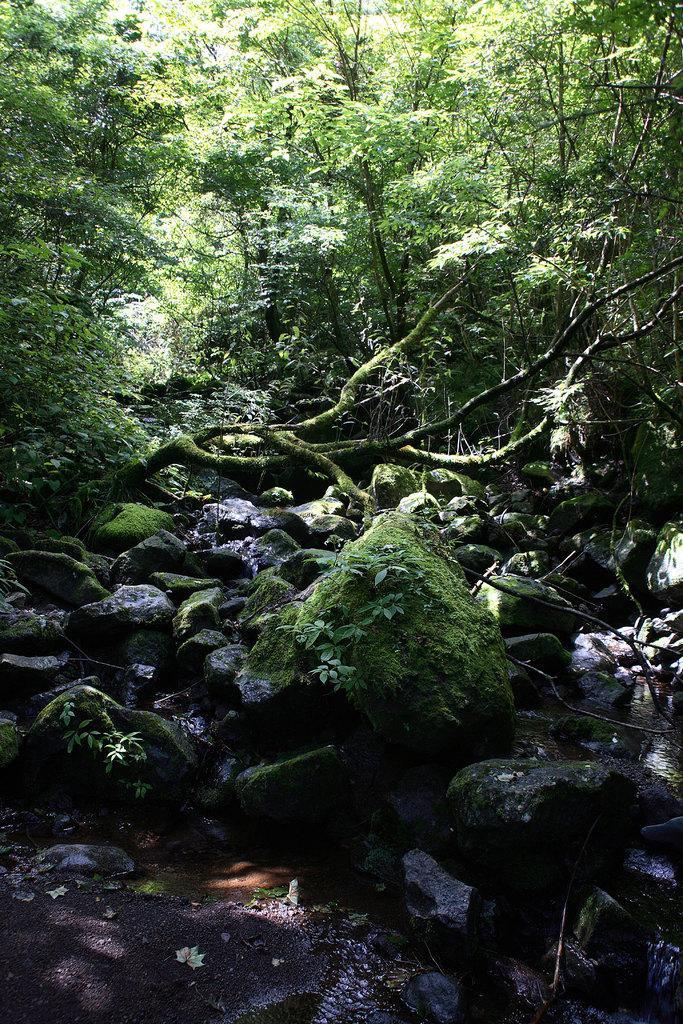Can you describe this image briefly? This picture might be taken from outside of the city. In this image, in the background, we can see some trees and plants, at the bottom, we can see some plants, wood trunks and some rocks. 